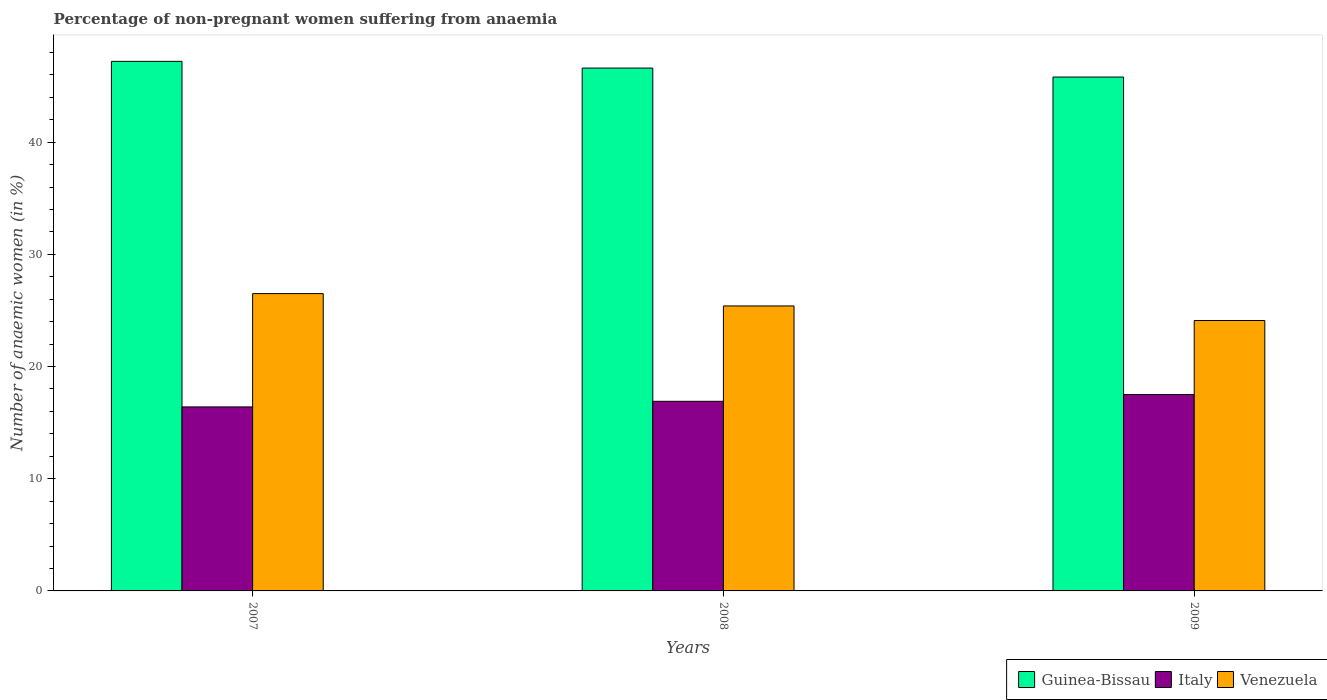How many different coloured bars are there?
Keep it short and to the point. 3. Are the number of bars per tick equal to the number of legend labels?
Give a very brief answer. Yes. How many bars are there on the 3rd tick from the right?
Ensure brevity in your answer.  3. What is the label of the 3rd group of bars from the left?
Make the answer very short. 2009. What is the percentage of non-pregnant women suffering from anaemia in Venezuela in 2009?
Keep it short and to the point. 24.1. Across all years, what is the minimum percentage of non-pregnant women suffering from anaemia in Venezuela?
Ensure brevity in your answer.  24.1. In which year was the percentage of non-pregnant women suffering from anaemia in Venezuela minimum?
Give a very brief answer. 2009. What is the total percentage of non-pregnant women suffering from anaemia in Venezuela in the graph?
Provide a short and direct response. 76. What is the difference between the percentage of non-pregnant women suffering from anaemia in Venezuela in 2007 and that in 2008?
Provide a succinct answer. 1.1. What is the difference between the percentage of non-pregnant women suffering from anaemia in Italy in 2008 and the percentage of non-pregnant women suffering from anaemia in Guinea-Bissau in 2009?
Your response must be concise. -28.9. What is the average percentage of non-pregnant women suffering from anaemia in Italy per year?
Your response must be concise. 16.93. In the year 2009, what is the difference between the percentage of non-pregnant women suffering from anaemia in Venezuela and percentage of non-pregnant women suffering from anaemia in Guinea-Bissau?
Provide a succinct answer. -21.7. In how many years, is the percentage of non-pregnant women suffering from anaemia in Guinea-Bissau greater than 10 %?
Your answer should be very brief. 3. What is the ratio of the percentage of non-pregnant women suffering from anaemia in Venezuela in 2007 to that in 2009?
Your answer should be very brief. 1.1. Is the percentage of non-pregnant women suffering from anaemia in Venezuela in 2007 less than that in 2009?
Offer a terse response. No. Is the difference between the percentage of non-pregnant women suffering from anaemia in Venezuela in 2008 and 2009 greater than the difference between the percentage of non-pregnant women suffering from anaemia in Guinea-Bissau in 2008 and 2009?
Your answer should be compact. Yes. What is the difference between the highest and the second highest percentage of non-pregnant women suffering from anaemia in Guinea-Bissau?
Keep it short and to the point. 0.6. What is the difference between the highest and the lowest percentage of non-pregnant women suffering from anaemia in Italy?
Your answer should be very brief. 1.1. In how many years, is the percentage of non-pregnant women suffering from anaemia in Italy greater than the average percentage of non-pregnant women suffering from anaemia in Italy taken over all years?
Your answer should be very brief. 1. What does the 1st bar from the left in 2007 represents?
Make the answer very short. Guinea-Bissau. What does the 2nd bar from the right in 2008 represents?
Make the answer very short. Italy. Are the values on the major ticks of Y-axis written in scientific E-notation?
Keep it short and to the point. No. Does the graph contain any zero values?
Your answer should be compact. No. What is the title of the graph?
Provide a short and direct response. Percentage of non-pregnant women suffering from anaemia. What is the label or title of the Y-axis?
Provide a short and direct response. Number of anaemic women (in %). What is the Number of anaemic women (in %) in Guinea-Bissau in 2007?
Make the answer very short. 47.2. What is the Number of anaemic women (in %) in Italy in 2007?
Make the answer very short. 16.4. What is the Number of anaemic women (in %) of Venezuela in 2007?
Your answer should be very brief. 26.5. What is the Number of anaemic women (in %) in Guinea-Bissau in 2008?
Make the answer very short. 46.6. What is the Number of anaemic women (in %) of Italy in 2008?
Provide a short and direct response. 16.9. What is the Number of anaemic women (in %) of Venezuela in 2008?
Your response must be concise. 25.4. What is the Number of anaemic women (in %) of Guinea-Bissau in 2009?
Make the answer very short. 45.8. What is the Number of anaemic women (in %) in Venezuela in 2009?
Offer a terse response. 24.1. Across all years, what is the maximum Number of anaemic women (in %) in Guinea-Bissau?
Provide a short and direct response. 47.2. Across all years, what is the maximum Number of anaemic women (in %) of Italy?
Offer a very short reply. 17.5. Across all years, what is the minimum Number of anaemic women (in %) of Guinea-Bissau?
Give a very brief answer. 45.8. Across all years, what is the minimum Number of anaemic women (in %) in Italy?
Provide a succinct answer. 16.4. Across all years, what is the minimum Number of anaemic women (in %) in Venezuela?
Your answer should be very brief. 24.1. What is the total Number of anaemic women (in %) in Guinea-Bissau in the graph?
Your answer should be compact. 139.6. What is the total Number of anaemic women (in %) in Italy in the graph?
Give a very brief answer. 50.8. What is the difference between the Number of anaemic women (in %) of Italy in 2007 and that in 2008?
Provide a short and direct response. -0.5. What is the difference between the Number of anaemic women (in %) of Guinea-Bissau in 2007 and that in 2009?
Your answer should be compact. 1.4. What is the difference between the Number of anaemic women (in %) in Guinea-Bissau in 2008 and that in 2009?
Make the answer very short. 0.8. What is the difference between the Number of anaemic women (in %) of Italy in 2008 and that in 2009?
Give a very brief answer. -0.6. What is the difference between the Number of anaemic women (in %) in Guinea-Bissau in 2007 and the Number of anaemic women (in %) in Italy in 2008?
Offer a very short reply. 30.3. What is the difference between the Number of anaemic women (in %) of Guinea-Bissau in 2007 and the Number of anaemic women (in %) of Venezuela in 2008?
Offer a very short reply. 21.8. What is the difference between the Number of anaemic women (in %) of Guinea-Bissau in 2007 and the Number of anaemic women (in %) of Italy in 2009?
Offer a very short reply. 29.7. What is the difference between the Number of anaemic women (in %) in Guinea-Bissau in 2007 and the Number of anaemic women (in %) in Venezuela in 2009?
Ensure brevity in your answer.  23.1. What is the difference between the Number of anaemic women (in %) of Guinea-Bissau in 2008 and the Number of anaemic women (in %) of Italy in 2009?
Provide a succinct answer. 29.1. What is the average Number of anaemic women (in %) of Guinea-Bissau per year?
Provide a succinct answer. 46.53. What is the average Number of anaemic women (in %) in Italy per year?
Ensure brevity in your answer.  16.93. What is the average Number of anaemic women (in %) of Venezuela per year?
Offer a terse response. 25.33. In the year 2007, what is the difference between the Number of anaemic women (in %) of Guinea-Bissau and Number of anaemic women (in %) of Italy?
Make the answer very short. 30.8. In the year 2007, what is the difference between the Number of anaemic women (in %) in Guinea-Bissau and Number of anaemic women (in %) in Venezuela?
Ensure brevity in your answer.  20.7. In the year 2007, what is the difference between the Number of anaemic women (in %) in Italy and Number of anaemic women (in %) in Venezuela?
Give a very brief answer. -10.1. In the year 2008, what is the difference between the Number of anaemic women (in %) of Guinea-Bissau and Number of anaemic women (in %) of Italy?
Offer a terse response. 29.7. In the year 2008, what is the difference between the Number of anaemic women (in %) of Guinea-Bissau and Number of anaemic women (in %) of Venezuela?
Keep it short and to the point. 21.2. In the year 2008, what is the difference between the Number of anaemic women (in %) of Italy and Number of anaemic women (in %) of Venezuela?
Provide a succinct answer. -8.5. In the year 2009, what is the difference between the Number of anaemic women (in %) in Guinea-Bissau and Number of anaemic women (in %) in Italy?
Provide a short and direct response. 28.3. In the year 2009, what is the difference between the Number of anaemic women (in %) in Guinea-Bissau and Number of anaemic women (in %) in Venezuela?
Your response must be concise. 21.7. In the year 2009, what is the difference between the Number of anaemic women (in %) in Italy and Number of anaemic women (in %) in Venezuela?
Ensure brevity in your answer.  -6.6. What is the ratio of the Number of anaemic women (in %) of Guinea-Bissau in 2007 to that in 2008?
Ensure brevity in your answer.  1.01. What is the ratio of the Number of anaemic women (in %) in Italy in 2007 to that in 2008?
Offer a terse response. 0.97. What is the ratio of the Number of anaemic women (in %) in Venezuela in 2007 to that in 2008?
Provide a short and direct response. 1.04. What is the ratio of the Number of anaemic women (in %) in Guinea-Bissau in 2007 to that in 2009?
Provide a succinct answer. 1.03. What is the ratio of the Number of anaemic women (in %) of Italy in 2007 to that in 2009?
Offer a terse response. 0.94. What is the ratio of the Number of anaemic women (in %) in Venezuela in 2007 to that in 2009?
Provide a short and direct response. 1.1. What is the ratio of the Number of anaemic women (in %) of Guinea-Bissau in 2008 to that in 2009?
Give a very brief answer. 1.02. What is the ratio of the Number of anaemic women (in %) of Italy in 2008 to that in 2009?
Provide a short and direct response. 0.97. What is the ratio of the Number of anaemic women (in %) in Venezuela in 2008 to that in 2009?
Keep it short and to the point. 1.05. What is the difference between the highest and the second highest Number of anaemic women (in %) of Guinea-Bissau?
Your response must be concise. 0.6. What is the difference between the highest and the lowest Number of anaemic women (in %) of Guinea-Bissau?
Make the answer very short. 1.4. 